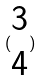Convert formula to latex. <formula><loc_0><loc_0><loc_500><loc_500>( \begin{matrix} 3 \\ 4 \end{matrix} )</formula> 